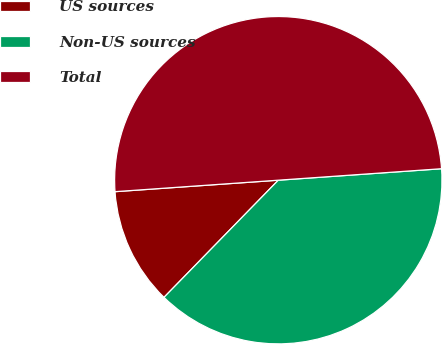Convert chart. <chart><loc_0><loc_0><loc_500><loc_500><pie_chart><fcel>US sources<fcel>Non-US sources<fcel>Total<nl><fcel>11.58%<fcel>38.42%<fcel>50.0%<nl></chart> 